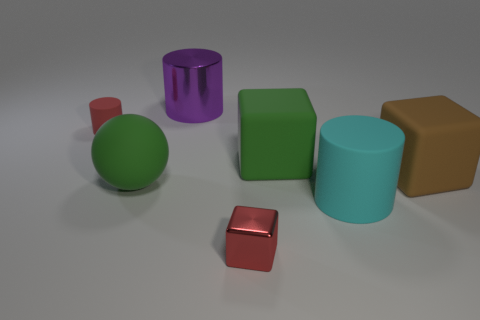There is a rubber cylinder to the right of the big purple cylinder; is its size the same as the matte block that is in front of the green rubber block?
Offer a terse response. Yes. What is the color of the large cylinder in front of the green matte thing in front of the big brown matte block?
Keep it short and to the point. Cyan. There is another cylinder that is the same size as the purple metallic cylinder; what is its material?
Your answer should be compact. Rubber. What number of rubber objects are either red blocks or big gray cylinders?
Your answer should be very brief. 0. What color is the thing that is to the left of the big purple cylinder and in front of the small matte object?
Offer a terse response. Green. There is a tiny red matte cylinder; what number of red shiny objects are on the right side of it?
Keep it short and to the point. 1. What is the material of the big cyan thing?
Your answer should be very brief. Rubber. There is a block that is on the left side of the large green matte thing behind the big green object that is on the left side of the purple thing; what color is it?
Make the answer very short. Red. What number of red metallic cubes are the same size as the cyan object?
Make the answer very short. 0. The tiny object that is on the left side of the large green matte ball is what color?
Provide a succinct answer. Red. 